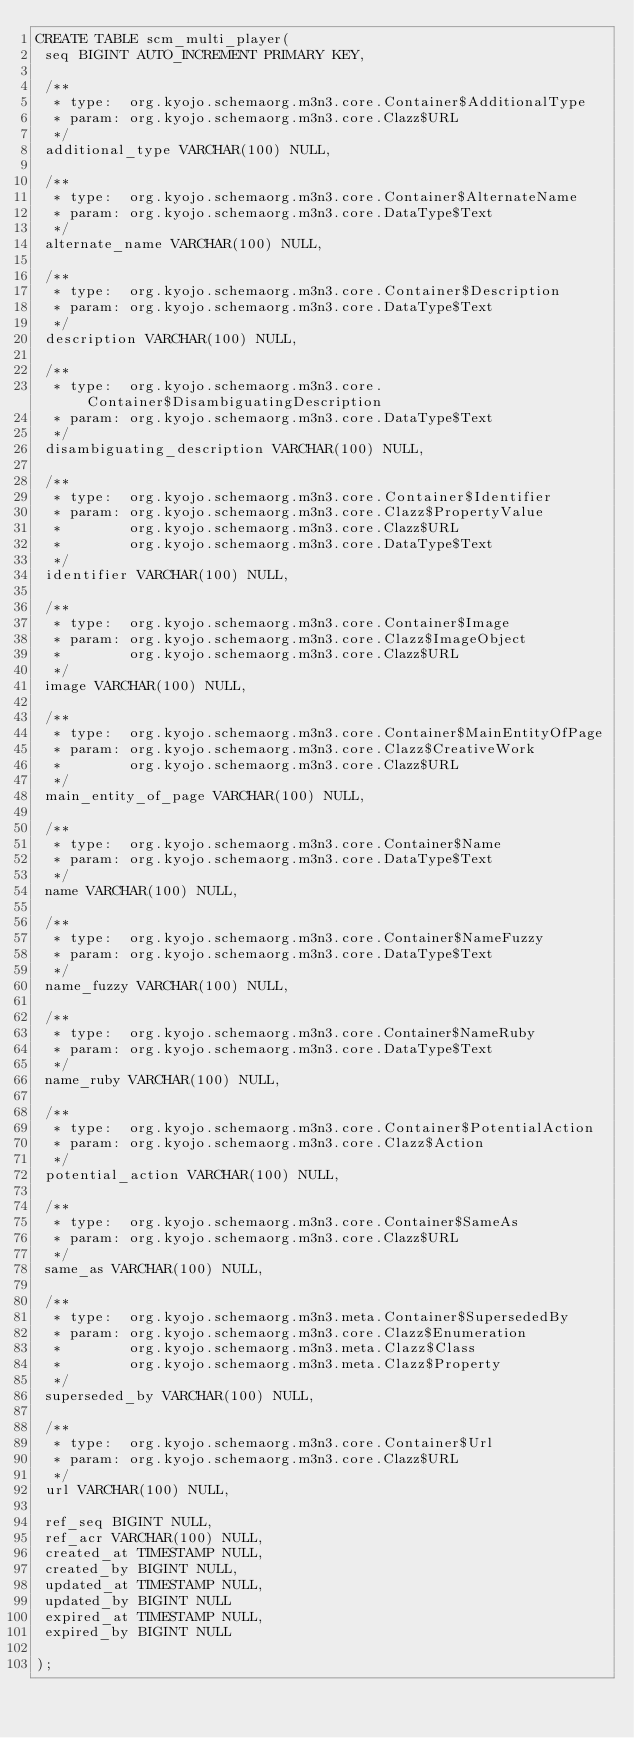<code> <loc_0><loc_0><loc_500><loc_500><_SQL_>CREATE TABLE scm_multi_player(
 seq BIGINT AUTO_INCREMENT PRIMARY KEY,

 /**
  * type:  org.kyojo.schemaorg.m3n3.core.Container$AdditionalType
  * param: org.kyojo.schemaorg.m3n3.core.Clazz$URL
  */
 additional_type VARCHAR(100) NULL,

 /**
  * type:  org.kyojo.schemaorg.m3n3.core.Container$AlternateName
  * param: org.kyojo.schemaorg.m3n3.core.DataType$Text
  */
 alternate_name VARCHAR(100) NULL,

 /**
  * type:  org.kyojo.schemaorg.m3n3.core.Container$Description
  * param: org.kyojo.schemaorg.m3n3.core.DataType$Text
  */
 description VARCHAR(100) NULL,

 /**
  * type:  org.kyojo.schemaorg.m3n3.core.Container$DisambiguatingDescription
  * param: org.kyojo.schemaorg.m3n3.core.DataType$Text
  */
 disambiguating_description VARCHAR(100) NULL,

 /**
  * type:  org.kyojo.schemaorg.m3n3.core.Container$Identifier
  * param: org.kyojo.schemaorg.m3n3.core.Clazz$PropertyValue
  *        org.kyojo.schemaorg.m3n3.core.Clazz$URL
  *        org.kyojo.schemaorg.m3n3.core.DataType$Text
  */
 identifier VARCHAR(100) NULL,

 /**
  * type:  org.kyojo.schemaorg.m3n3.core.Container$Image
  * param: org.kyojo.schemaorg.m3n3.core.Clazz$ImageObject
  *        org.kyojo.schemaorg.m3n3.core.Clazz$URL
  */
 image VARCHAR(100) NULL,

 /**
  * type:  org.kyojo.schemaorg.m3n3.core.Container$MainEntityOfPage
  * param: org.kyojo.schemaorg.m3n3.core.Clazz$CreativeWork
  *        org.kyojo.schemaorg.m3n3.core.Clazz$URL
  */
 main_entity_of_page VARCHAR(100) NULL,

 /**
  * type:  org.kyojo.schemaorg.m3n3.core.Container$Name
  * param: org.kyojo.schemaorg.m3n3.core.DataType$Text
  */
 name VARCHAR(100) NULL,

 /**
  * type:  org.kyojo.schemaorg.m3n3.core.Container$NameFuzzy
  * param: org.kyojo.schemaorg.m3n3.core.DataType$Text
  */
 name_fuzzy VARCHAR(100) NULL,

 /**
  * type:  org.kyojo.schemaorg.m3n3.core.Container$NameRuby
  * param: org.kyojo.schemaorg.m3n3.core.DataType$Text
  */
 name_ruby VARCHAR(100) NULL,

 /**
  * type:  org.kyojo.schemaorg.m3n3.core.Container$PotentialAction
  * param: org.kyojo.schemaorg.m3n3.core.Clazz$Action
  */
 potential_action VARCHAR(100) NULL,

 /**
  * type:  org.kyojo.schemaorg.m3n3.core.Container$SameAs
  * param: org.kyojo.schemaorg.m3n3.core.Clazz$URL
  */
 same_as VARCHAR(100) NULL,

 /**
  * type:  org.kyojo.schemaorg.m3n3.meta.Container$SupersededBy
  * param: org.kyojo.schemaorg.m3n3.core.Clazz$Enumeration
  *        org.kyojo.schemaorg.m3n3.meta.Clazz$Class
  *        org.kyojo.schemaorg.m3n3.meta.Clazz$Property
  */
 superseded_by VARCHAR(100) NULL,

 /**
  * type:  org.kyojo.schemaorg.m3n3.core.Container$Url
  * param: org.kyojo.schemaorg.m3n3.core.Clazz$URL
  */
 url VARCHAR(100) NULL,

 ref_seq BIGINT NULL,
 ref_acr VARCHAR(100) NULL,
 created_at TIMESTAMP NULL,
 created_by BIGINT NULL,
 updated_at TIMESTAMP NULL,
 updated_by BIGINT NULL
 expired_at TIMESTAMP NULL,
 expired_by BIGINT NULL

);</code> 